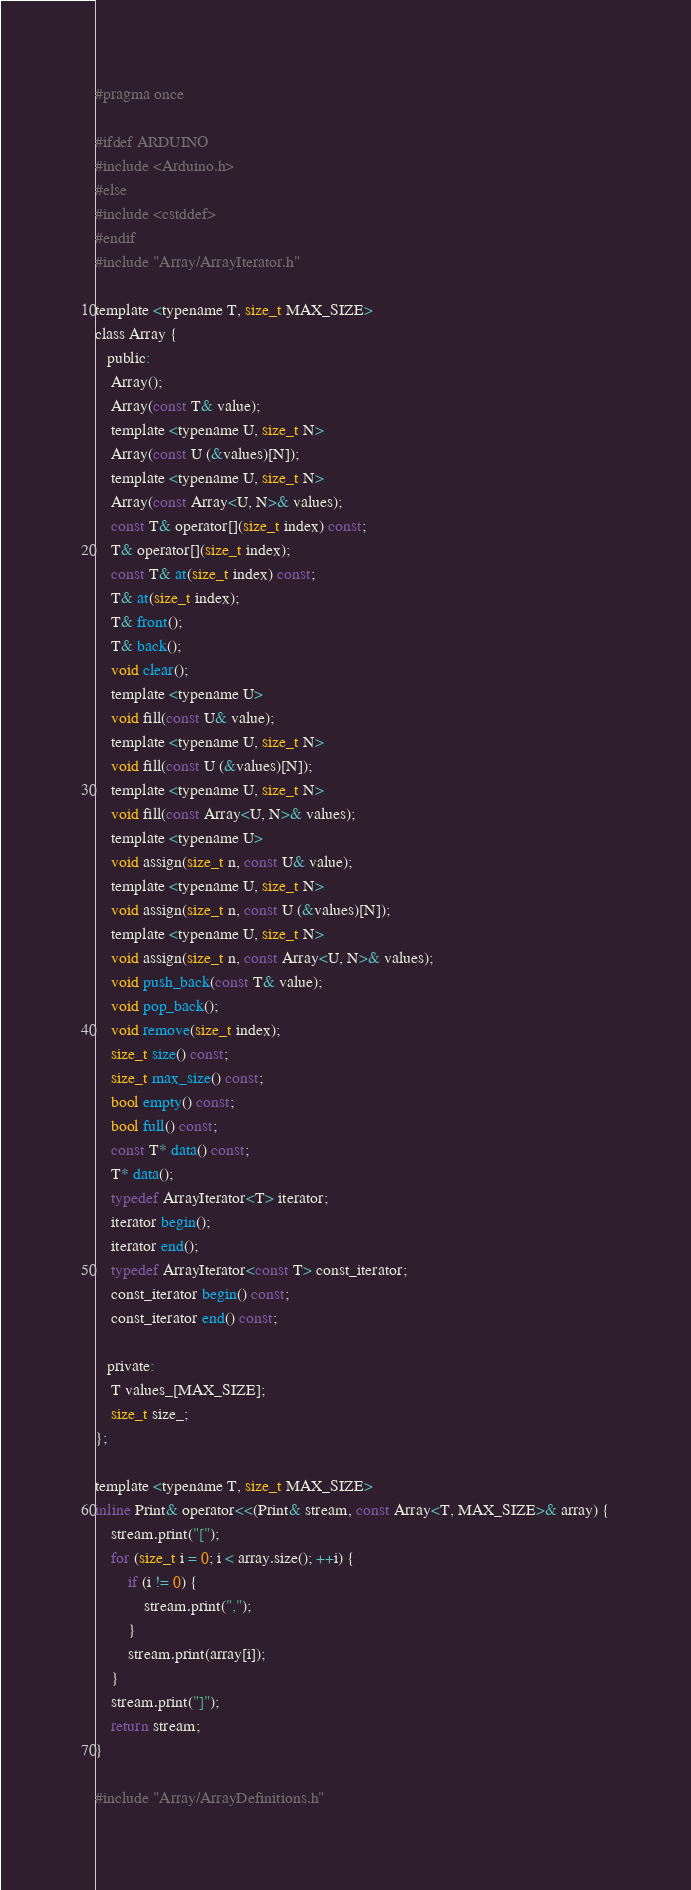<code> <loc_0><loc_0><loc_500><loc_500><_C_>#pragma once

#ifdef ARDUINO
#include <Arduino.h>
#else
#include <cstddef>
#endif
#include "Array/ArrayIterator.h"

template <typename T, size_t MAX_SIZE>
class Array {
   public:
    Array();
    Array(const T& value);
    template <typename U, size_t N>
    Array(const U (&values)[N]);
    template <typename U, size_t N>
    Array(const Array<U, N>& values);
    const T& operator[](size_t index) const;
    T& operator[](size_t index);
    const T& at(size_t index) const;
    T& at(size_t index);
    T& front();
    T& back();
    void clear();
    template <typename U>
    void fill(const U& value);
    template <typename U, size_t N>
    void fill(const U (&values)[N]);
    template <typename U, size_t N>
    void fill(const Array<U, N>& values);
    template <typename U>
    void assign(size_t n, const U& value);
    template <typename U, size_t N>
    void assign(size_t n, const U (&values)[N]);
    template <typename U, size_t N>
    void assign(size_t n, const Array<U, N>& values);
    void push_back(const T& value);
    void pop_back();
    void remove(size_t index);
    size_t size() const;
    size_t max_size() const;
    bool empty() const;
    bool full() const;
    const T* data() const;
    T* data();
    typedef ArrayIterator<T> iterator;
    iterator begin();
    iterator end();
    typedef ArrayIterator<const T> const_iterator;
    const_iterator begin() const;
    const_iterator end() const;

   private:
    T values_[MAX_SIZE];
    size_t size_;
};

template <typename T, size_t MAX_SIZE>
inline Print& operator<<(Print& stream, const Array<T, MAX_SIZE>& array) {
    stream.print("[");
    for (size_t i = 0; i < array.size(); ++i) {
        if (i != 0) {
            stream.print(",");
        }
        stream.print(array[i]);
    }
    stream.print("]");
    return stream;
}

#include "Array/ArrayDefinitions.h"</code> 